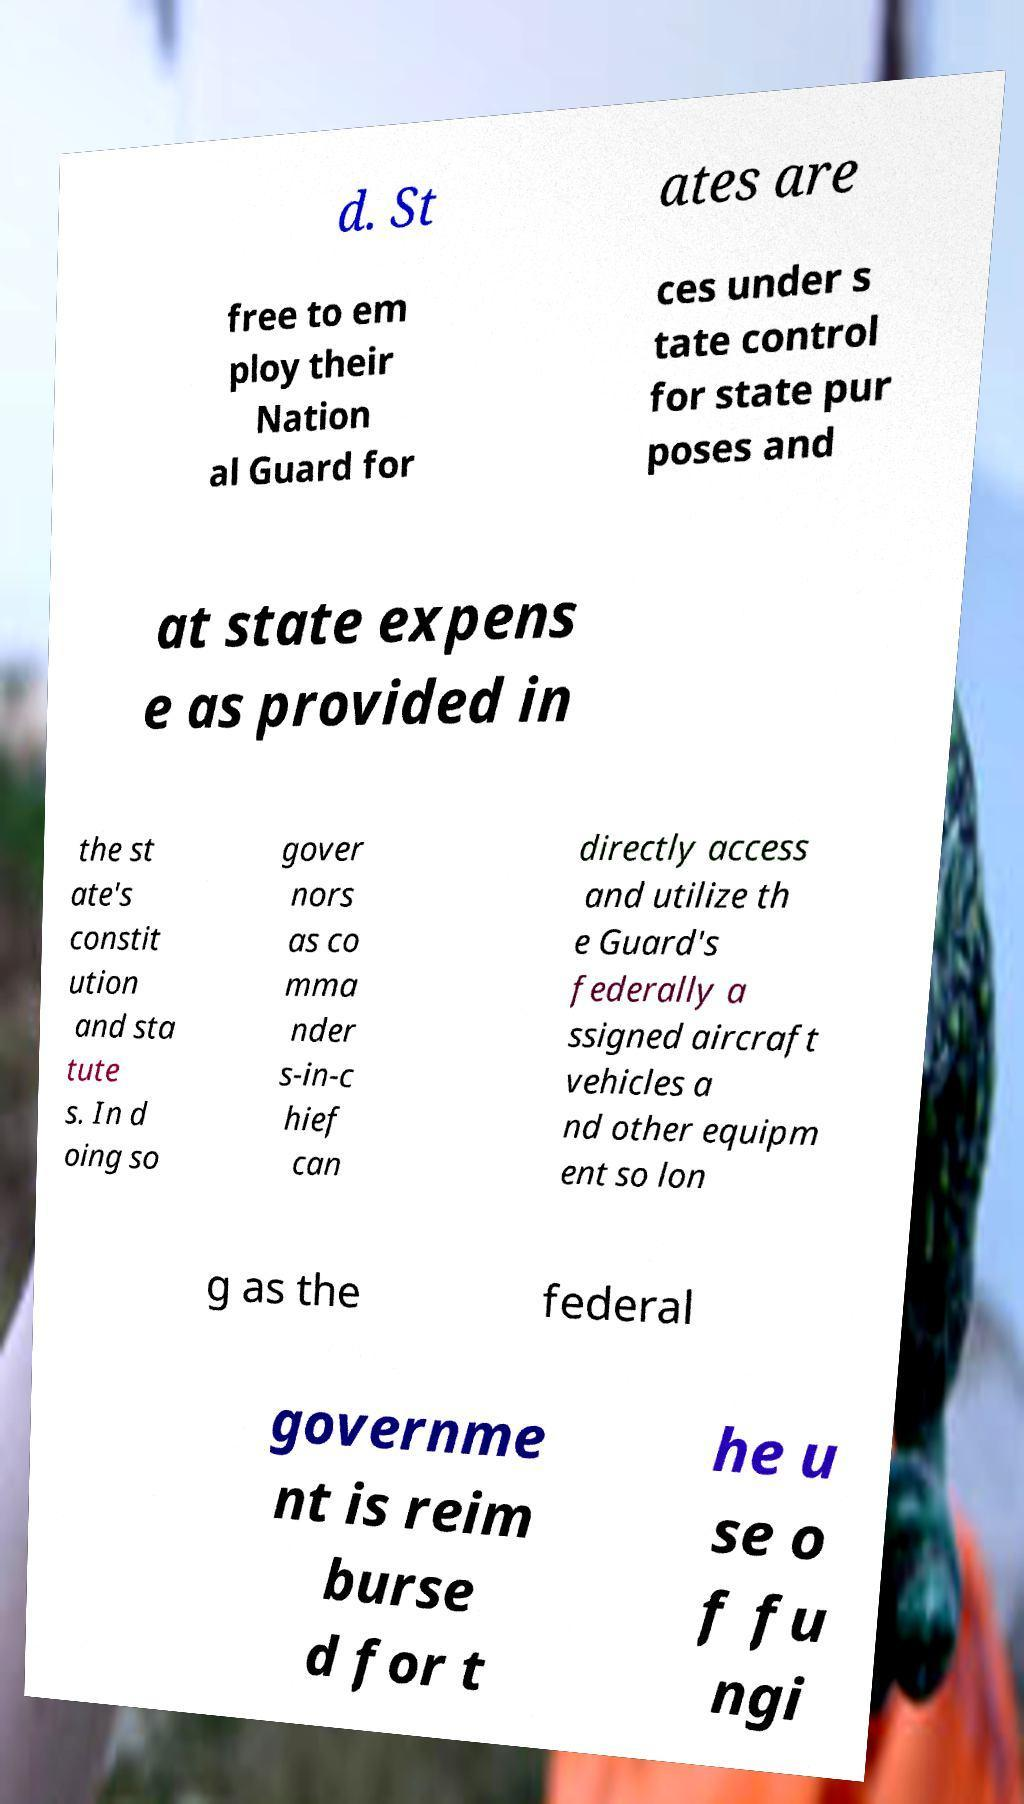Can you accurately transcribe the text from the provided image for me? d. St ates are free to em ploy their Nation al Guard for ces under s tate control for state pur poses and at state expens e as provided in the st ate's constit ution and sta tute s. In d oing so gover nors as co mma nder s-in-c hief can directly access and utilize th e Guard's federally a ssigned aircraft vehicles a nd other equipm ent so lon g as the federal governme nt is reim burse d for t he u se o f fu ngi 